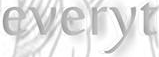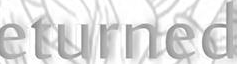Identify the words shown in these images in order, separated by a semicolon. everyt; eturned 